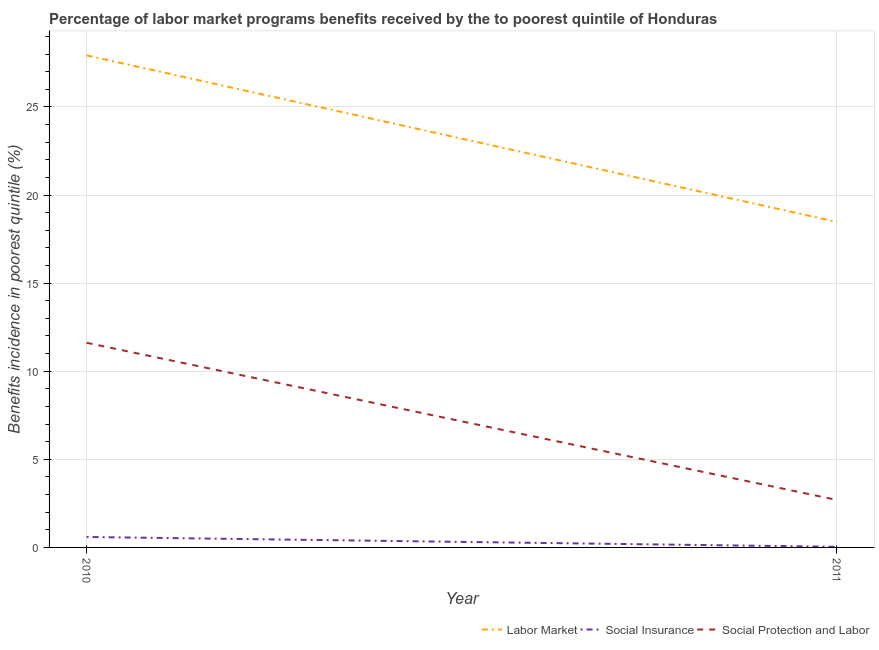Does the line corresponding to percentage of benefits received due to labor market programs intersect with the line corresponding to percentage of benefits received due to social insurance programs?
Ensure brevity in your answer.  No. Is the number of lines equal to the number of legend labels?
Offer a very short reply. Yes. What is the percentage of benefits received due to labor market programs in 2011?
Make the answer very short. 18.47. Across all years, what is the maximum percentage of benefits received due to social protection programs?
Keep it short and to the point. 11.61. Across all years, what is the minimum percentage of benefits received due to social insurance programs?
Give a very brief answer. 0.03. What is the total percentage of benefits received due to social protection programs in the graph?
Your answer should be very brief. 14.31. What is the difference between the percentage of benefits received due to labor market programs in 2010 and that in 2011?
Make the answer very short. 9.45. What is the difference between the percentage of benefits received due to social protection programs in 2010 and the percentage of benefits received due to social insurance programs in 2011?
Offer a terse response. 11.58. What is the average percentage of benefits received due to social insurance programs per year?
Offer a very short reply. 0.31. In the year 2010, what is the difference between the percentage of benefits received due to labor market programs and percentage of benefits received due to social insurance programs?
Offer a terse response. 27.33. What is the ratio of the percentage of benefits received due to labor market programs in 2010 to that in 2011?
Your answer should be very brief. 1.51. Is the percentage of benefits received due to social protection programs in 2010 less than that in 2011?
Keep it short and to the point. No. In how many years, is the percentage of benefits received due to social protection programs greater than the average percentage of benefits received due to social protection programs taken over all years?
Provide a succinct answer. 1. Is it the case that in every year, the sum of the percentage of benefits received due to labor market programs and percentage of benefits received due to social insurance programs is greater than the percentage of benefits received due to social protection programs?
Keep it short and to the point. Yes. Is the percentage of benefits received due to social insurance programs strictly less than the percentage of benefits received due to labor market programs over the years?
Provide a succinct answer. Yes. What is the difference between two consecutive major ticks on the Y-axis?
Your answer should be compact. 5. Are the values on the major ticks of Y-axis written in scientific E-notation?
Provide a succinct answer. No. Does the graph contain grids?
Your response must be concise. Yes. Where does the legend appear in the graph?
Keep it short and to the point. Bottom right. What is the title of the graph?
Keep it short and to the point. Percentage of labor market programs benefits received by the to poorest quintile of Honduras. Does "Ages 0-14" appear as one of the legend labels in the graph?
Your response must be concise. No. What is the label or title of the Y-axis?
Your answer should be compact. Benefits incidence in poorest quintile (%). What is the Benefits incidence in poorest quintile (%) in Labor Market in 2010?
Provide a short and direct response. 27.92. What is the Benefits incidence in poorest quintile (%) of Social Insurance in 2010?
Your answer should be very brief. 0.59. What is the Benefits incidence in poorest quintile (%) in Social Protection and Labor in 2010?
Offer a very short reply. 11.61. What is the Benefits incidence in poorest quintile (%) in Labor Market in 2011?
Provide a succinct answer. 18.47. What is the Benefits incidence in poorest quintile (%) of Social Insurance in 2011?
Keep it short and to the point. 0.03. What is the Benefits incidence in poorest quintile (%) of Social Protection and Labor in 2011?
Ensure brevity in your answer.  2.69. Across all years, what is the maximum Benefits incidence in poorest quintile (%) of Labor Market?
Ensure brevity in your answer.  27.92. Across all years, what is the maximum Benefits incidence in poorest quintile (%) of Social Insurance?
Offer a terse response. 0.59. Across all years, what is the maximum Benefits incidence in poorest quintile (%) of Social Protection and Labor?
Offer a very short reply. 11.61. Across all years, what is the minimum Benefits incidence in poorest quintile (%) in Labor Market?
Your answer should be compact. 18.47. Across all years, what is the minimum Benefits incidence in poorest quintile (%) of Social Insurance?
Provide a succinct answer. 0.03. Across all years, what is the minimum Benefits incidence in poorest quintile (%) of Social Protection and Labor?
Provide a short and direct response. 2.69. What is the total Benefits incidence in poorest quintile (%) in Labor Market in the graph?
Provide a short and direct response. 46.39. What is the total Benefits incidence in poorest quintile (%) of Social Insurance in the graph?
Keep it short and to the point. 0.63. What is the total Benefits incidence in poorest quintile (%) of Social Protection and Labor in the graph?
Make the answer very short. 14.31. What is the difference between the Benefits incidence in poorest quintile (%) of Labor Market in 2010 and that in 2011?
Your answer should be compact. 9.45. What is the difference between the Benefits incidence in poorest quintile (%) of Social Insurance in 2010 and that in 2011?
Give a very brief answer. 0.56. What is the difference between the Benefits incidence in poorest quintile (%) of Social Protection and Labor in 2010 and that in 2011?
Offer a very short reply. 8.92. What is the difference between the Benefits incidence in poorest quintile (%) of Labor Market in 2010 and the Benefits incidence in poorest quintile (%) of Social Insurance in 2011?
Provide a succinct answer. 27.89. What is the difference between the Benefits incidence in poorest quintile (%) of Labor Market in 2010 and the Benefits incidence in poorest quintile (%) of Social Protection and Labor in 2011?
Make the answer very short. 25.23. What is the difference between the Benefits incidence in poorest quintile (%) of Social Insurance in 2010 and the Benefits incidence in poorest quintile (%) of Social Protection and Labor in 2011?
Give a very brief answer. -2.1. What is the average Benefits incidence in poorest quintile (%) of Labor Market per year?
Provide a short and direct response. 23.2. What is the average Benefits incidence in poorest quintile (%) in Social Insurance per year?
Make the answer very short. 0.31. What is the average Benefits incidence in poorest quintile (%) in Social Protection and Labor per year?
Provide a short and direct response. 7.15. In the year 2010, what is the difference between the Benefits incidence in poorest quintile (%) of Labor Market and Benefits incidence in poorest quintile (%) of Social Insurance?
Offer a very short reply. 27.33. In the year 2010, what is the difference between the Benefits incidence in poorest quintile (%) in Labor Market and Benefits incidence in poorest quintile (%) in Social Protection and Labor?
Ensure brevity in your answer.  16.31. In the year 2010, what is the difference between the Benefits incidence in poorest quintile (%) in Social Insurance and Benefits incidence in poorest quintile (%) in Social Protection and Labor?
Provide a short and direct response. -11.02. In the year 2011, what is the difference between the Benefits incidence in poorest quintile (%) in Labor Market and Benefits incidence in poorest quintile (%) in Social Insurance?
Offer a terse response. 18.44. In the year 2011, what is the difference between the Benefits incidence in poorest quintile (%) in Labor Market and Benefits incidence in poorest quintile (%) in Social Protection and Labor?
Give a very brief answer. 15.78. In the year 2011, what is the difference between the Benefits incidence in poorest quintile (%) of Social Insurance and Benefits incidence in poorest quintile (%) of Social Protection and Labor?
Your response must be concise. -2.66. What is the ratio of the Benefits incidence in poorest quintile (%) of Labor Market in 2010 to that in 2011?
Provide a succinct answer. 1.51. What is the ratio of the Benefits incidence in poorest quintile (%) in Social Insurance in 2010 to that in 2011?
Your answer should be compact. 17.11. What is the ratio of the Benefits incidence in poorest quintile (%) in Social Protection and Labor in 2010 to that in 2011?
Your answer should be compact. 4.31. What is the difference between the highest and the second highest Benefits incidence in poorest quintile (%) in Labor Market?
Make the answer very short. 9.45. What is the difference between the highest and the second highest Benefits incidence in poorest quintile (%) in Social Insurance?
Offer a very short reply. 0.56. What is the difference between the highest and the second highest Benefits incidence in poorest quintile (%) of Social Protection and Labor?
Offer a very short reply. 8.92. What is the difference between the highest and the lowest Benefits incidence in poorest quintile (%) of Labor Market?
Keep it short and to the point. 9.45. What is the difference between the highest and the lowest Benefits incidence in poorest quintile (%) of Social Insurance?
Your answer should be compact. 0.56. What is the difference between the highest and the lowest Benefits incidence in poorest quintile (%) of Social Protection and Labor?
Offer a terse response. 8.92. 